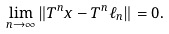Convert formula to latex. <formula><loc_0><loc_0><loc_500><loc_500>\lim _ { n \to \infty } \| T ^ { n } x - T ^ { n } \ell _ { n } \| = 0 .</formula> 